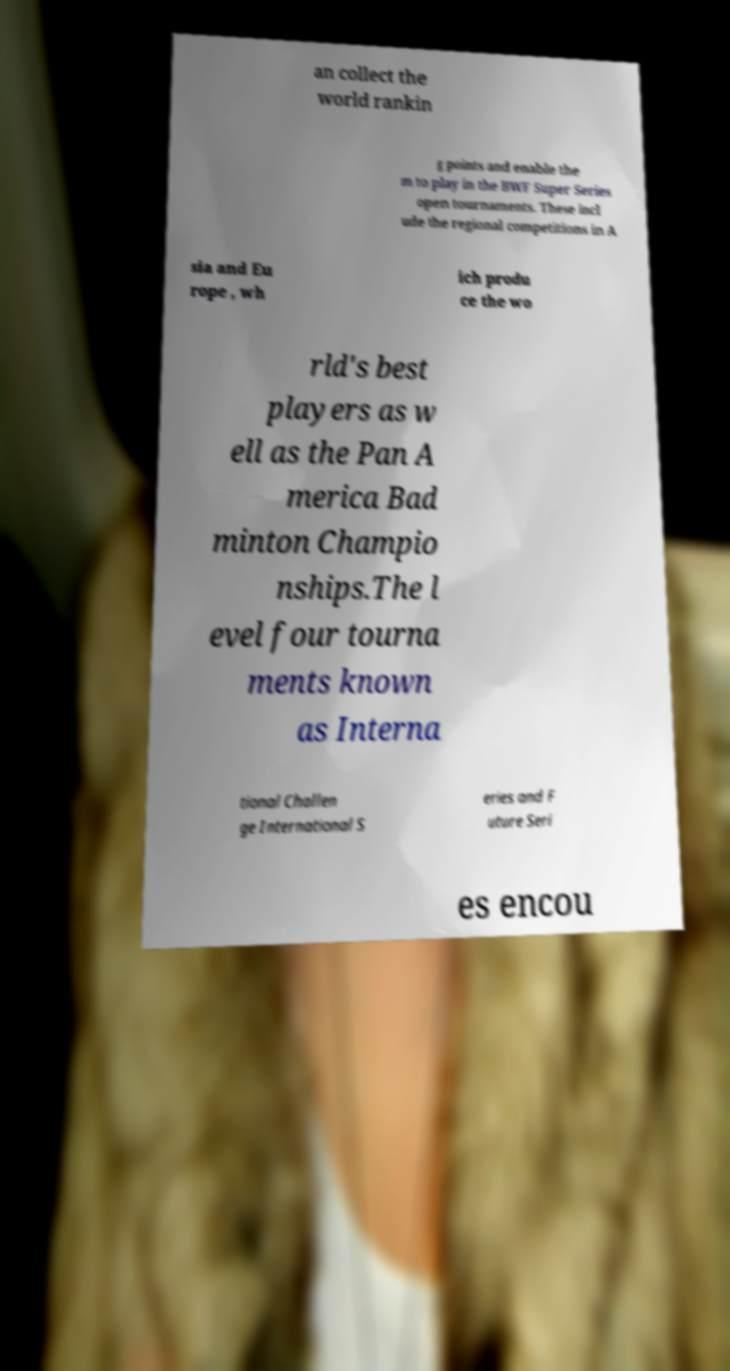Can you accurately transcribe the text from the provided image for me? an collect the world rankin g points and enable the m to play in the BWF Super Series open tournaments. These incl ude the regional competitions in A sia and Eu rope , wh ich produ ce the wo rld's best players as w ell as the Pan A merica Bad minton Champio nships.The l evel four tourna ments known as Interna tional Challen ge International S eries and F uture Seri es encou 